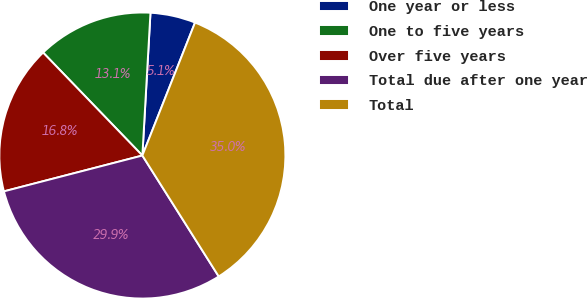Convert chart. <chart><loc_0><loc_0><loc_500><loc_500><pie_chart><fcel>One year or less<fcel>One to five years<fcel>Over five years<fcel>Total due after one year<fcel>Total<nl><fcel>5.1%<fcel>13.11%<fcel>16.82%<fcel>29.93%<fcel>35.03%<nl></chart> 